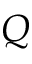Convert formula to latex. <formula><loc_0><loc_0><loc_500><loc_500>Q</formula> 